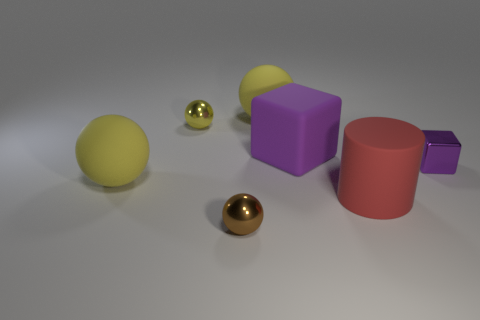Subtract all yellow spheres. How many were subtracted if there are1yellow spheres left? 2 Add 2 tiny brown metallic spheres. How many objects exist? 9 Subtract all brown balls. How many balls are left? 3 Subtract all blue blocks. How many yellow spheres are left? 3 Subtract all brown balls. How many balls are left? 3 Subtract all cubes. How many objects are left? 5 Subtract 1 red cylinders. How many objects are left? 6 Subtract 1 blocks. How many blocks are left? 1 Subtract all blue cylinders. Subtract all blue balls. How many cylinders are left? 1 Subtract all yellow shiny things. Subtract all yellow things. How many objects are left? 3 